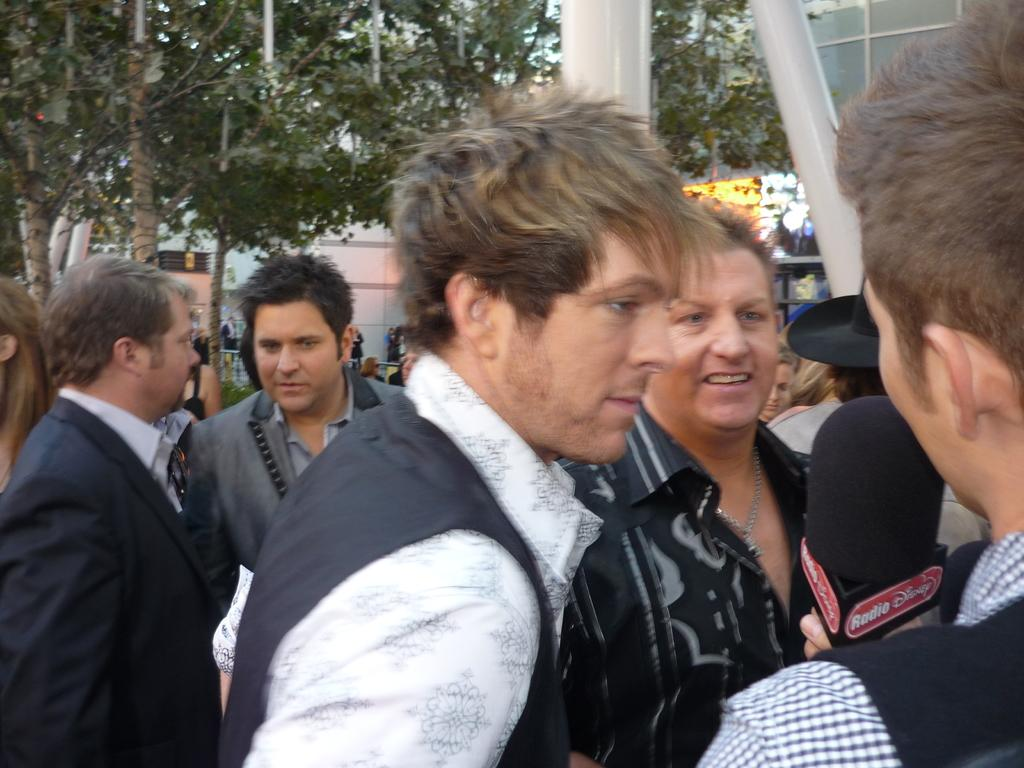How many people are present in the image? There are many persons in the image. What are the persons in the image doing? The persons are talking to each other. What can be seen in the background of the image? There are trees, buildings, and persons visible in the background of the image. What is visible in the sky in the image? The sky is visible in the background of the image. What type of chalk is being used to draw on the buildings in the image? There is no chalk or drawing activity present in the image. How does the destruction of the buildings affect the persons in the image? There is no destruction of buildings or any negative impact on the persons in the image. 